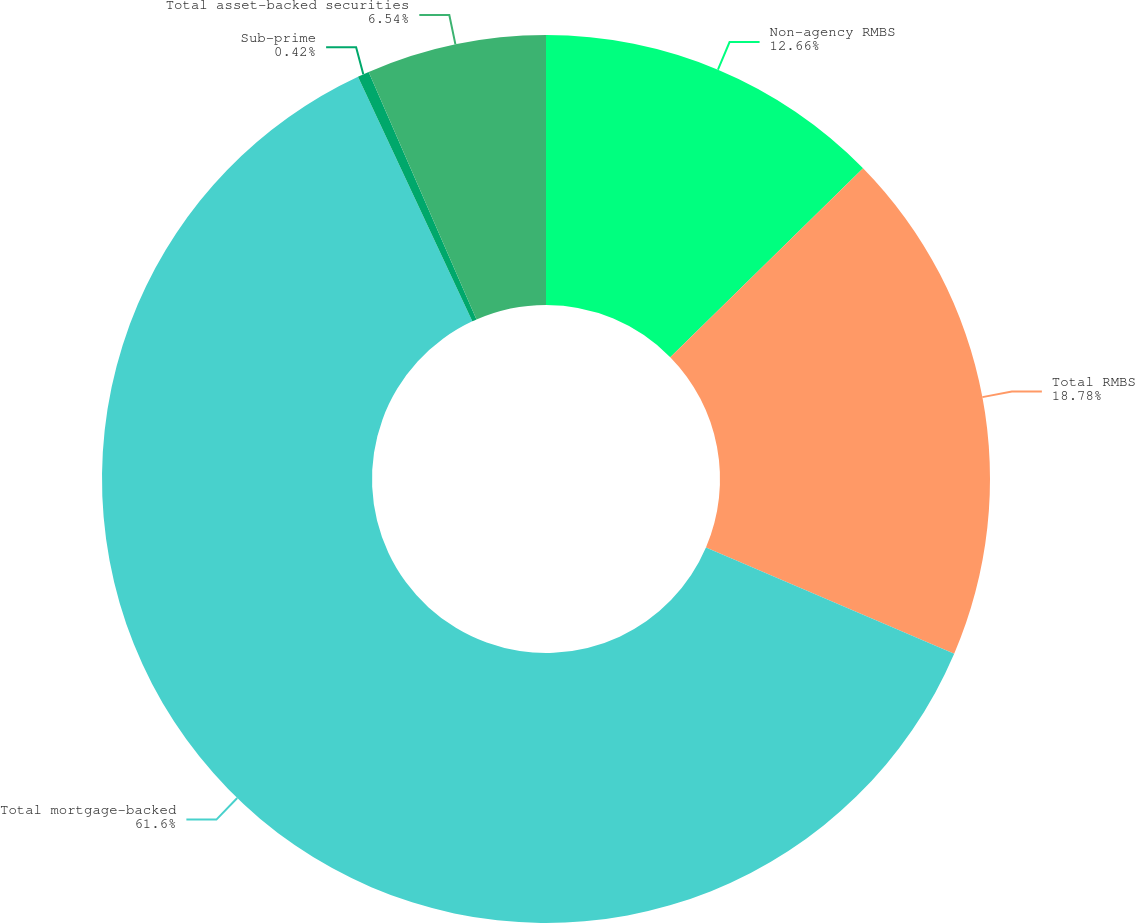<chart> <loc_0><loc_0><loc_500><loc_500><pie_chart><fcel>Non-agency RMBS<fcel>Total RMBS<fcel>Total mortgage-backed<fcel>Sub-prime<fcel>Total asset-backed securities<nl><fcel>12.66%<fcel>18.78%<fcel>61.61%<fcel>0.42%<fcel>6.54%<nl></chart> 